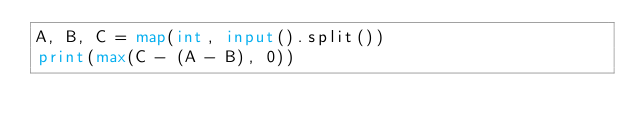Convert code to text. <code><loc_0><loc_0><loc_500><loc_500><_Python_>A, B, C = map(int, input().split())
print(max(C - (A - B), 0))
</code> 